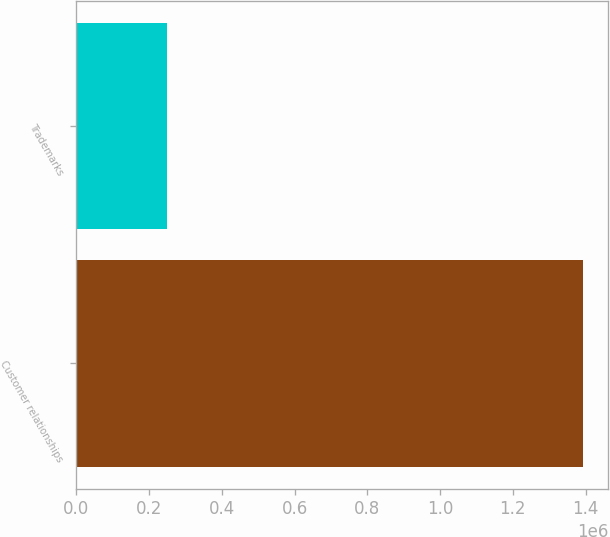Convert chart. <chart><loc_0><loc_0><loc_500><loc_500><bar_chart><fcel>Customer relationships<fcel>Trademarks<nl><fcel>1.39223e+06<fcel>249726<nl></chart> 